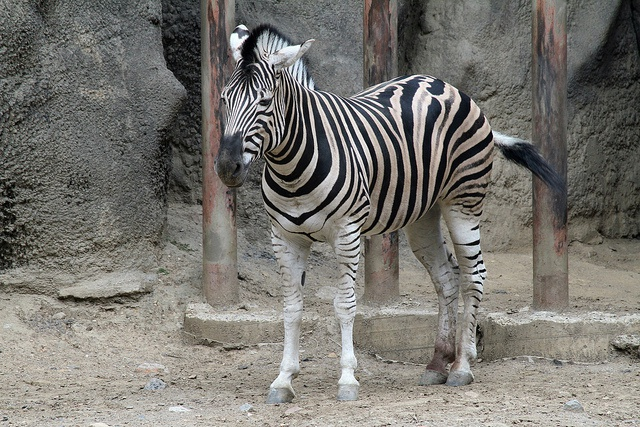Describe the objects in this image and their specific colors. I can see a zebra in gray, black, darkgray, and lightgray tones in this image. 